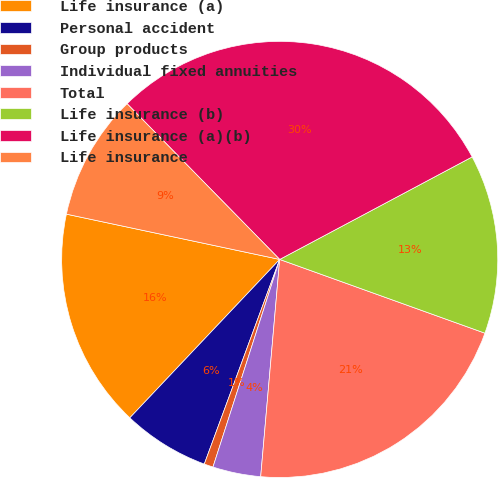Convert chart. <chart><loc_0><loc_0><loc_500><loc_500><pie_chart><fcel>Life insurance (a)<fcel>Personal accident<fcel>Group products<fcel>Individual fixed annuities<fcel>Total<fcel>Life insurance (b)<fcel>Life insurance (a)(b)<fcel>Life insurance<nl><fcel>16.27%<fcel>6.44%<fcel>0.67%<fcel>3.56%<fcel>20.9%<fcel>13.28%<fcel>29.55%<fcel>9.33%<nl></chart> 